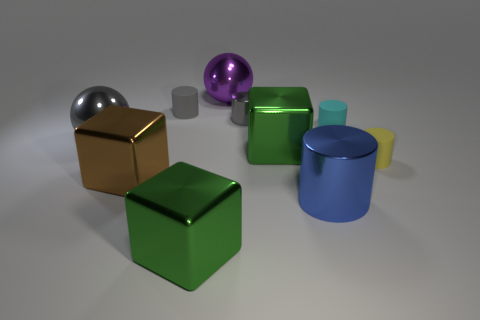What is the shape of the gray shiny object to the left of the large metallic object behind the large gray ball?
Provide a short and direct response. Sphere. What shape is the yellow thing?
Make the answer very short. Cylinder. What is the big green block in front of the small rubber cylinder that is in front of the cyan rubber cylinder that is behind the large brown block made of?
Offer a terse response. Metal. How many other objects are there of the same material as the big brown cube?
Your answer should be compact. 6. What number of large green shiny objects are behind the tiny matte thing in front of the cyan object?
Ensure brevity in your answer.  1. How many blocks are either objects or blue shiny things?
Make the answer very short. 3. What is the color of the thing that is both right of the tiny gray metallic cylinder and on the left side of the blue metal object?
Offer a terse response. Green. Are there any other things that are the same color as the small metal cylinder?
Offer a terse response. Yes. The small matte cylinder left of the big green shiny cube that is to the right of the large purple sphere is what color?
Give a very brief answer. Gray. Do the cyan matte thing and the yellow rubber thing have the same size?
Offer a terse response. Yes. 